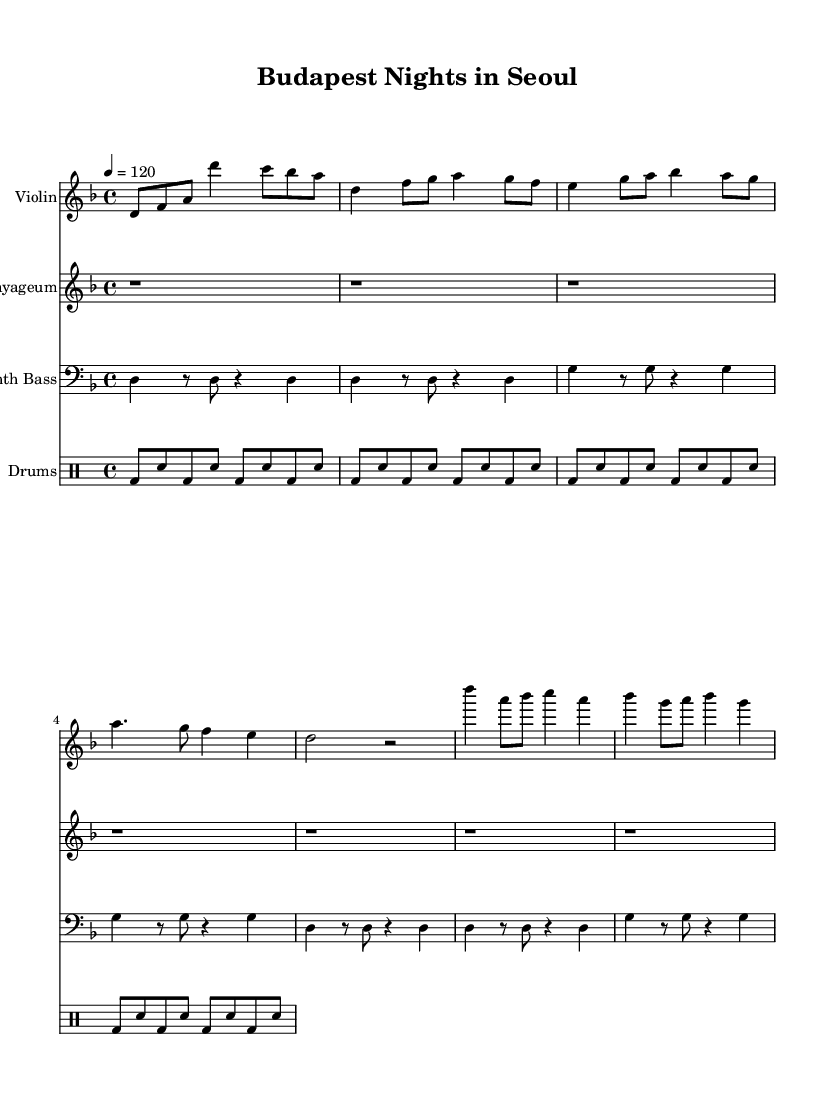What is the key signature of this music? The key signature is D minor, which is indicated by one flat (B flat). D minor is the relative minor of F major.
Answer: D minor What is the time signature of this music? The time signature is 4/4, which indicates that there are four beats in each measure, and the quarter note receives one beat. This is a common time signature in many music genres, including K-Pop.
Answer: 4/4 What is the tempo marking for this piece? The tempo is marked at 120 beats per minute, meaning the piece should be played at a moderately fast pace, suitable for dance-oriented K-Pop styles.
Answer: 120 How many measures are present in the violin part? The violin part consists of a total of 8 measures, which can be counted by identifying the separate groups of notes that are enclosed within bar lines.
Answer: 8 Which instruments are featured in this score? The score features four instruments: Violin, Gayageum, Synth Bass, and Drums. Each part is indicated with its own staff, making it easy to distinguish them visually.
Answer: Violin, Gayageum, Synth Bass, Drums What is the rhythmic pattern used in the drum part? The drum part consists of a basic electronic drum pattern using kick drums (bd) and snare drums (sn) in a repetitive sequence. This pattern aligns well with typical K-Pop production techniques.
Answer: Electronic drum pattern What is the relationship between the violin and Gayageum parts? The violin and Gayageum parts complement each other, with the violin providing a melodic line, while the Gayageum part remains simplified as a placeholder, which is common in K-Pop to allow focus on the main melody.
Answer: Complementary 